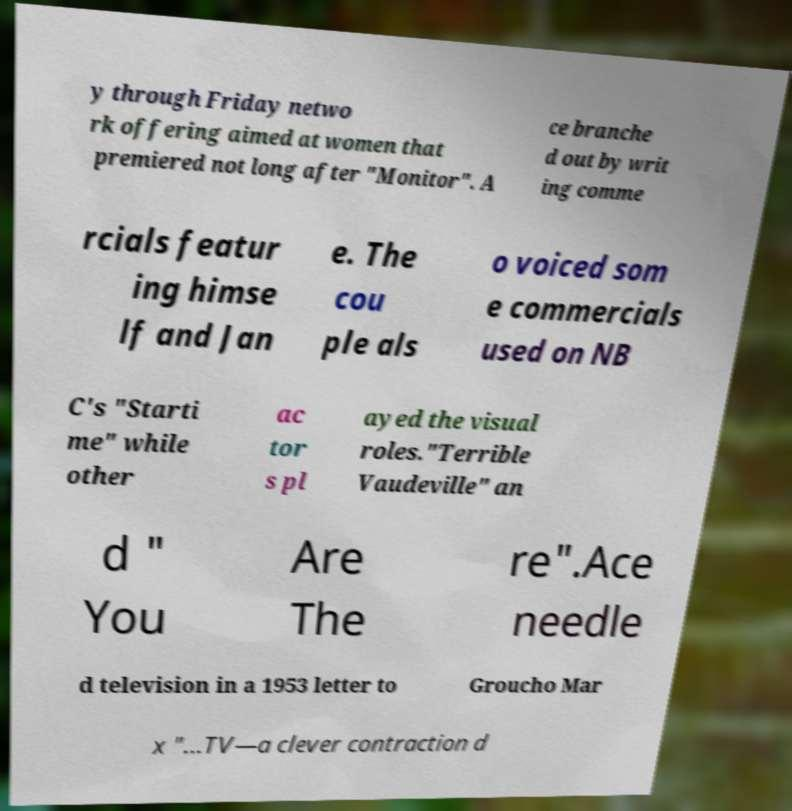Can you accurately transcribe the text from the provided image for me? y through Friday netwo rk offering aimed at women that premiered not long after "Monitor". A ce branche d out by writ ing comme rcials featur ing himse lf and Jan e. The cou ple als o voiced som e commercials used on NB C's "Starti me" while other ac tor s pl ayed the visual roles."Terrible Vaudeville" an d " You Are The re".Ace needle d television in a 1953 letter to Groucho Mar x "...TV—a clever contraction d 